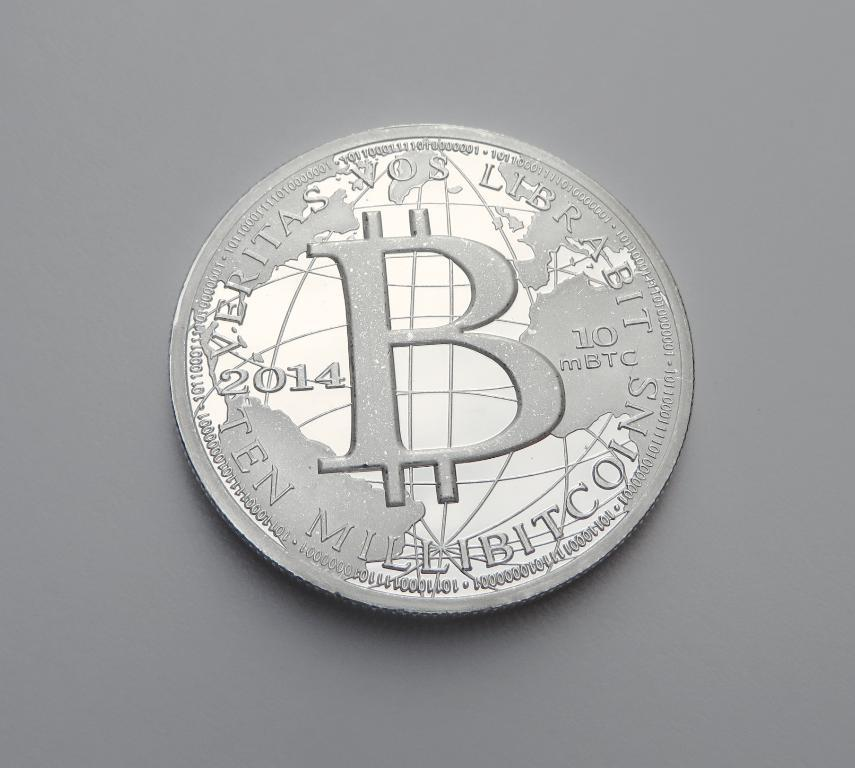<image>
Render a clear and concise summary of the photo. a 2014 silver coin with the letter B in the middle 